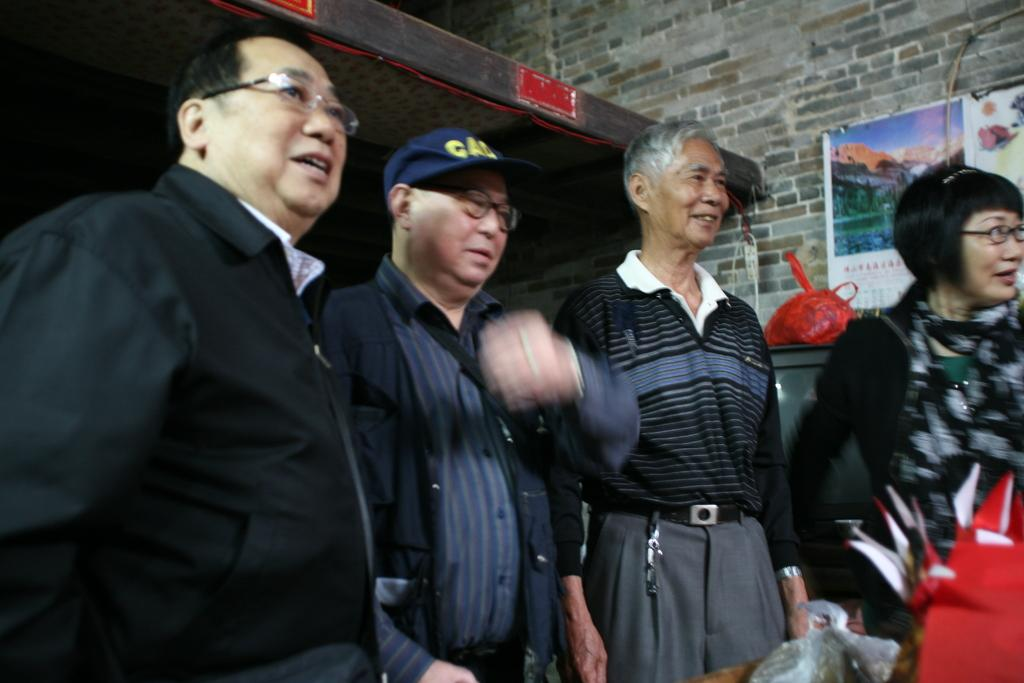What is happening in the image? There are people standing in the image. What else can be seen in the image besides the people? There is an object in the image. What is the condition of the television in the background of the image? There is a cover on a television in the background of the image. What decorations are present on the wall in the background of the image? There are posters on the wall in the background of the image. What type of paper is the bear holding in the image? There is no bear or paper present in the image. 